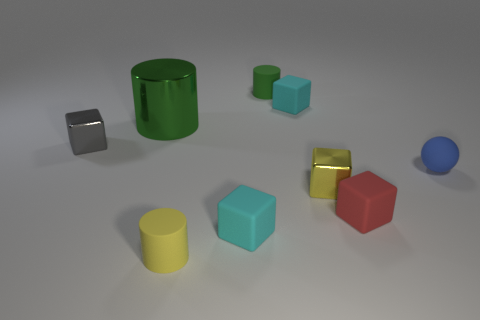Subtract all gray shiny cubes. How many cubes are left? 4 Subtract all green cylinders. How many cylinders are left? 1 Subtract 3 blocks. How many blocks are left? 2 Subtract all cylinders. How many objects are left? 6 Add 1 large yellow things. How many objects exist? 10 Subtract all cyan cylinders. How many blue cubes are left? 0 Subtract all red matte things. Subtract all purple things. How many objects are left? 8 Add 9 small blue objects. How many small blue objects are left? 10 Add 6 tiny gray objects. How many tiny gray objects exist? 7 Subtract 0 cyan spheres. How many objects are left? 9 